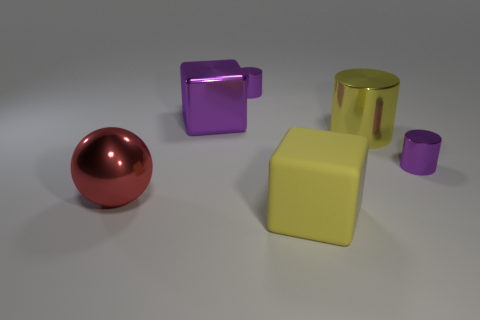Is the color of the large metal cylinder the same as the rubber object?
Offer a terse response. Yes. What is the shape of the other large thing that is the same color as the big matte thing?
Your answer should be very brief. Cylinder. There is a metallic cylinder that is the same color as the rubber block; what is its size?
Your response must be concise. Large. There is a object in front of the metallic sphere; what is its color?
Your response must be concise. Yellow. Is the size of the red object the same as the rubber thing?
Your response must be concise. Yes. What material is the large block in front of the tiny purple cylinder that is to the right of the large cylinder made of?
Give a very brief answer. Rubber. What number of big cylinders are the same color as the metal block?
Provide a succinct answer. 0. Is there any other thing that is made of the same material as the big yellow block?
Your answer should be very brief. No. Is the number of small purple objects to the right of the big yellow matte block less than the number of purple shiny objects?
Provide a succinct answer. Yes. The tiny metallic cylinder to the right of the yellow rubber cube that is in front of the large red metal sphere is what color?
Ensure brevity in your answer.  Purple. 